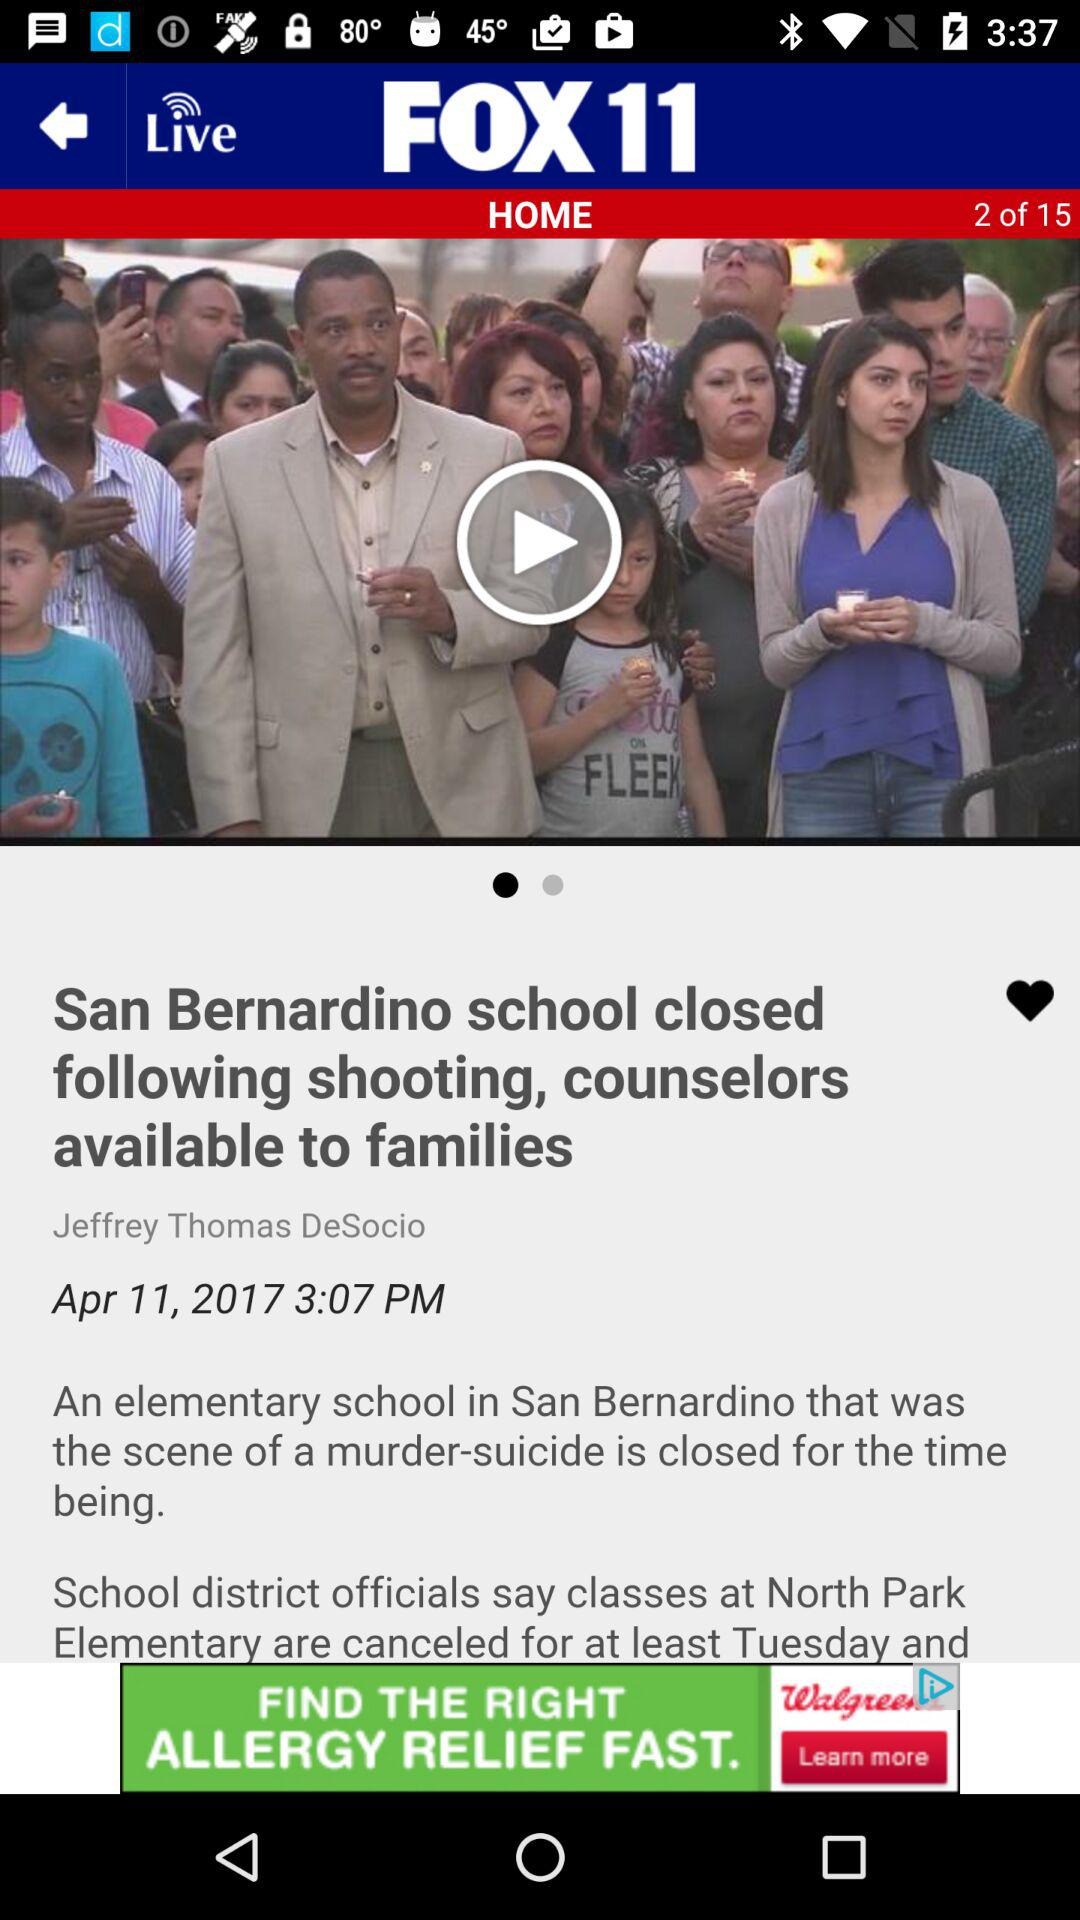What is the publication date? The publication date is April 11, 2017. 